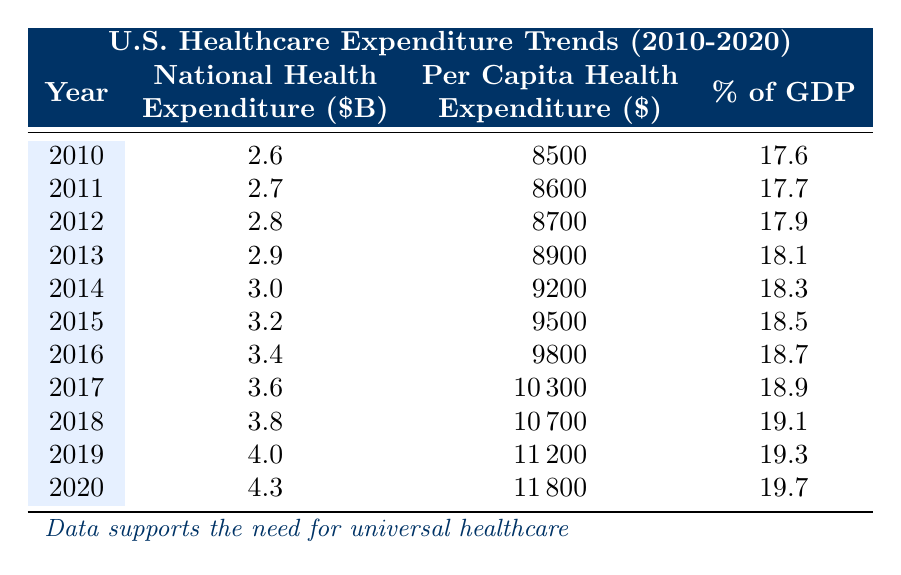What was the National Health Expenditure in 2014? The value for National Health Expenditure in 2014 is listed in the table. It shows that in 2014, the National Health Expenditure was 3.0 billion dollars.
Answer: 3.0 billion dollars What was the Per Capita Health Expenditure in 2018? By looking at the table, the value for Per Capita Health Expenditure in 2018 is provided. It states that in that year, the expenditure was 10,700 dollars.
Answer: 10,700 dollars Which year saw the highest percentage of GDP dedicated to healthcare? The table provides a percentage of GDP for each year from 2010 to 2020. By scanning through the values, 19.7% in 2020 is the highest percentage noted.
Answer: 19.7% What is the increase in National Health Expenditure from 2010 to 2020? The National Health Expenditure in 2010 is 2.6 billion dollars and in 2020, it is 4.3 billion dollars. To find the increase, we subtract: 4.3 - 2.6 = 1.7 billion dollars.
Answer: 1.7 billion dollars Is it true that the Per Capita Health Expenditure was above 10,000 dollars in 2016? The Per Capita Health Expenditure for 2016 is stated in the table as 9,800 dollars, which is less than 10,000. Thus, this statement is false.
Answer: No What was the average percentage of GDP for healthcare from 2010 to 2020? To find the average percentage of GDP, we must sum up the percentages for all years: (17.6 + 17.7 + 17.9 + 18.1 + 18.3 + 18.5 + 18.7 + 18.9 + 19.1 + 19.3 + 19.7) =  208.9. Then, we divide this sum by the total number of years (11): 208.9 / 11 = 19.0 (approximately).
Answer: 19.0 In which year did the National Health Expenditure first exceed 3 billion dollars? Looking at the table, 3 billion dollars was first reached in 2014. Therefore, the first year exceeding that amount is also 2014.
Answer: 2014 How many years had a Per Capita Health Expenditure less than 9,000 dollars? The years with a Per Capita Health Expenditure less than 9,000 dollars are 2010, 2011, 2012, and 2013. Counting these, we find that there are 4 such years.
Answer: 4 years 